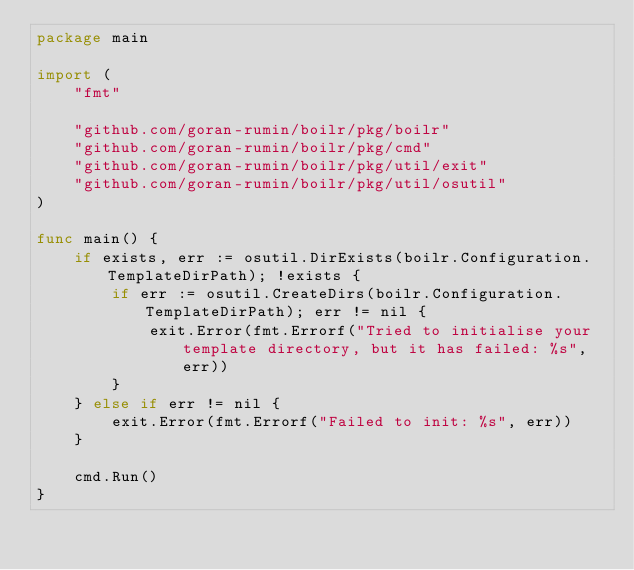<code> <loc_0><loc_0><loc_500><loc_500><_Go_>package main

import (
	"fmt"

	"github.com/goran-rumin/boilr/pkg/boilr"
	"github.com/goran-rumin/boilr/pkg/cmd"
	"github.com/goran-rumin/boilr/pkg/util/exit"
	"github.com/goran-rumin/boilr/pkg/util/osutil"
)

func main() {
	if exists, err := osutil.DirExists(boilr.Configuration.TemplateDirPath); !exists {
		if err := osutil.CreateDirs(boilr.Configuration.TemplateDirPath); err != nil {
			exit.Error(fmt.Errorf("Tried to initialise your template directory, but it has failed: %s", err))
		}
	} else if err != nil {
		exit.Error(fmt.Errorf("Failed to init: %s", err))
	}

	cmd.Run()
}
</code> 